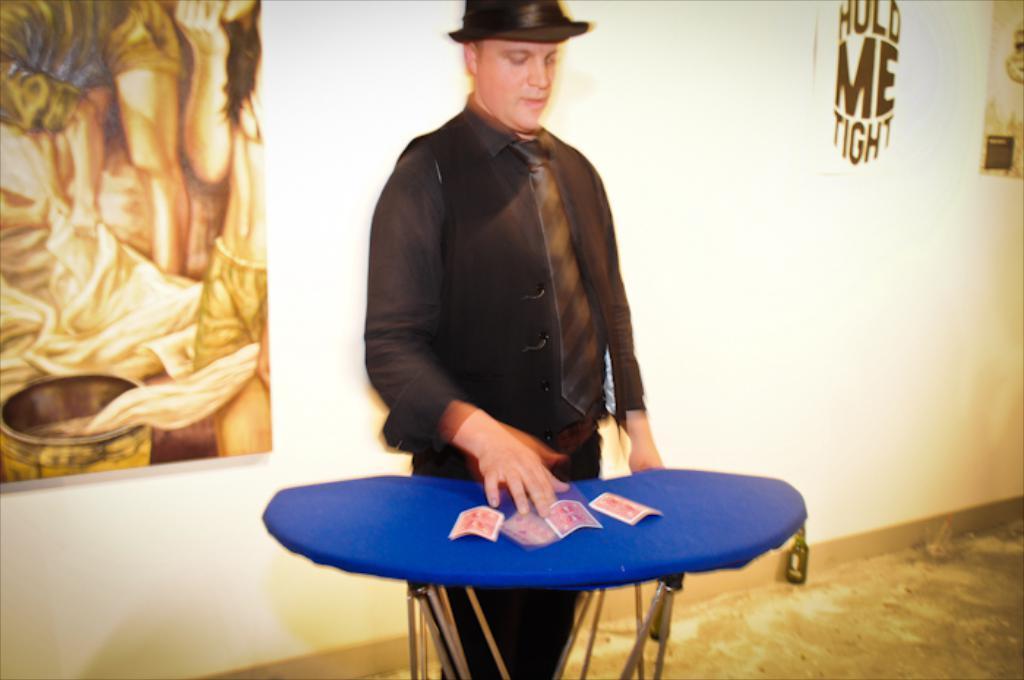Please provide a concise description of this image. In the middle of the image there is a table with cards. Behind the table there is a man with a hat on his head. Behind the man there is a wall with a frame and a poster. 